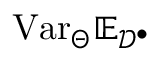Convert formula to latex. <formula><loc_0><loc_0><loc_500><loc_500>V a r _ { \Theta } \mathbb { E } _ { \mathcal { D } ^ { \bullet } }</formula> 